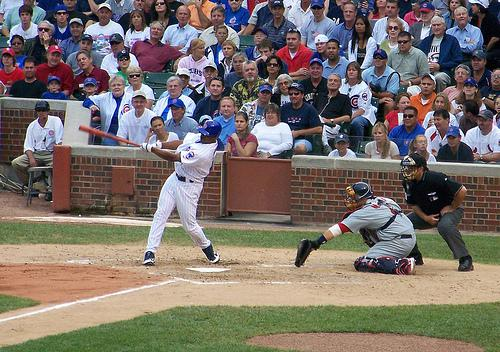Question: what team is that?
Choices:
A. Chicago Bears.
B. Dallas Cowboys.
C. The Cubs.
D. Chiefs.
Answer with the letter. Answer: C Question: when was the photo taken?
Choices:
A. Saturday.
B. Sunday.
C. Friday.
D. Monday.
Answer with the letter. Answer: A 